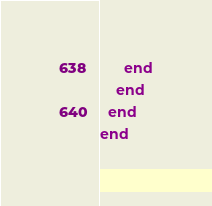Convert code to text. <code><loc_0><loc_0><loc_500><loc_500><_Ruby_>      end
    end
  end
end
</code> 